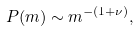Convert formula to latex. <formula><loc_0><loc_0><loc_500><loc_500>P ( m ) \sim m ^ { - ( 1 + \nu ) } ,</formula> 